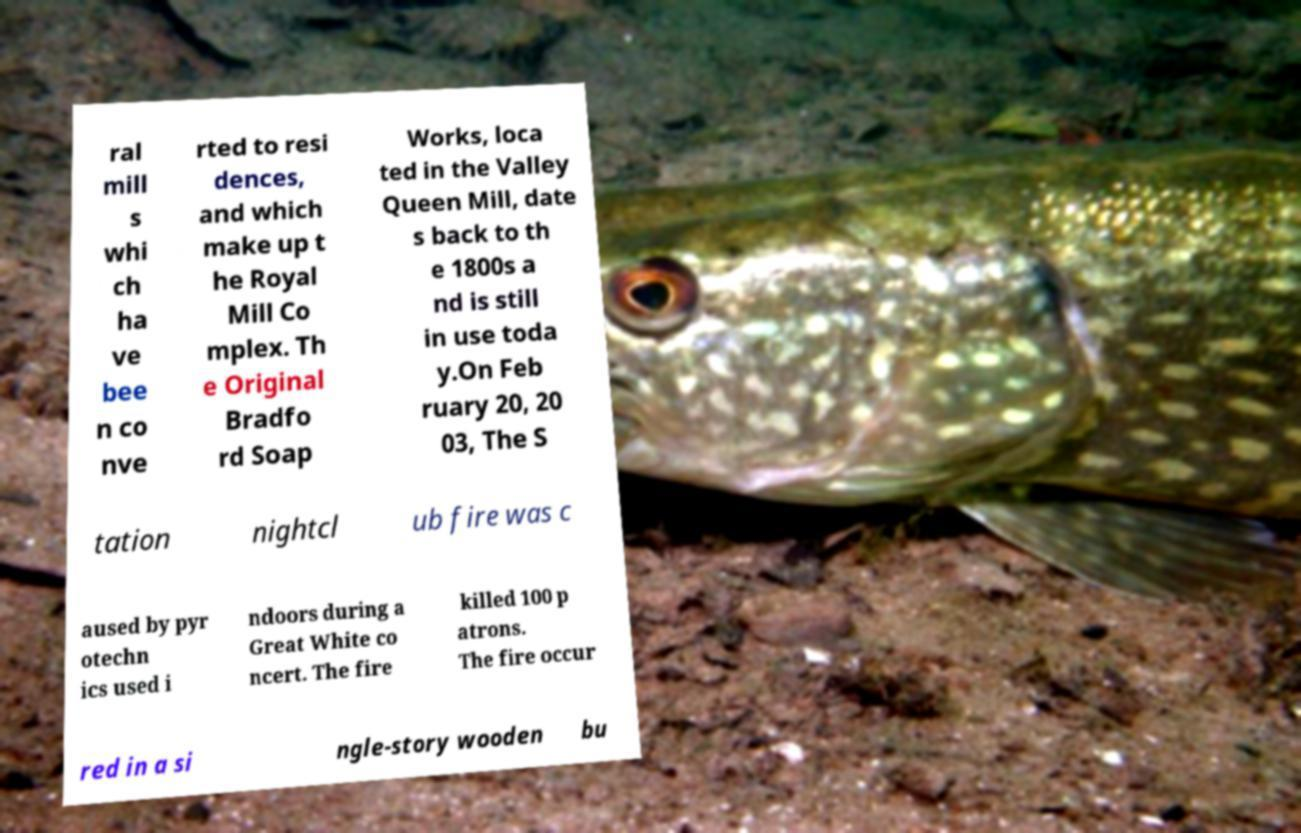Please identify and transcribe the text found in this image. ral mill s whi ch ha ve bee n co nve rted to resi dences, and which make up t he Royal Mill Co mplex. Th e Original Bradfo rd Soap Works, loca ted in the Valley Queen Mill, date s back to th e 1800s a nd is still in use toda y.On Feb ruary 20, 20 03, The S tation nightcl ub fire was c aused by pyr otechn ics used i ndoors during a Great White co ncert. The fire killed 100 p atrons. The fire occur red in a si ngle-story wooden bu 